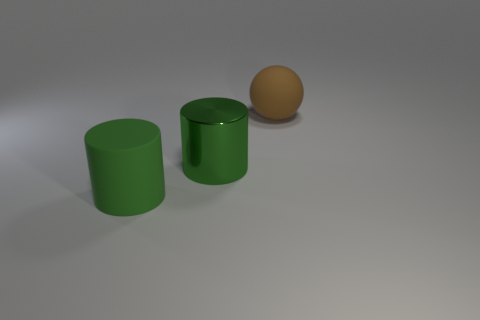Add 3 green objects. How many objects exist? 6 Subtract all cylinders. How many objects are left? 1 Subtract all small gray rubber cubes. Subtract all large green cylinders. How many objects are left? 1 Add 3 large green matte cylinders. How many large green matte cylinders are left? 4 Add 1 small blue rubber cylinders. How many small blue rubber cylinders exist? 1 Subtract 0 red spheres. How many objects are left? 3 